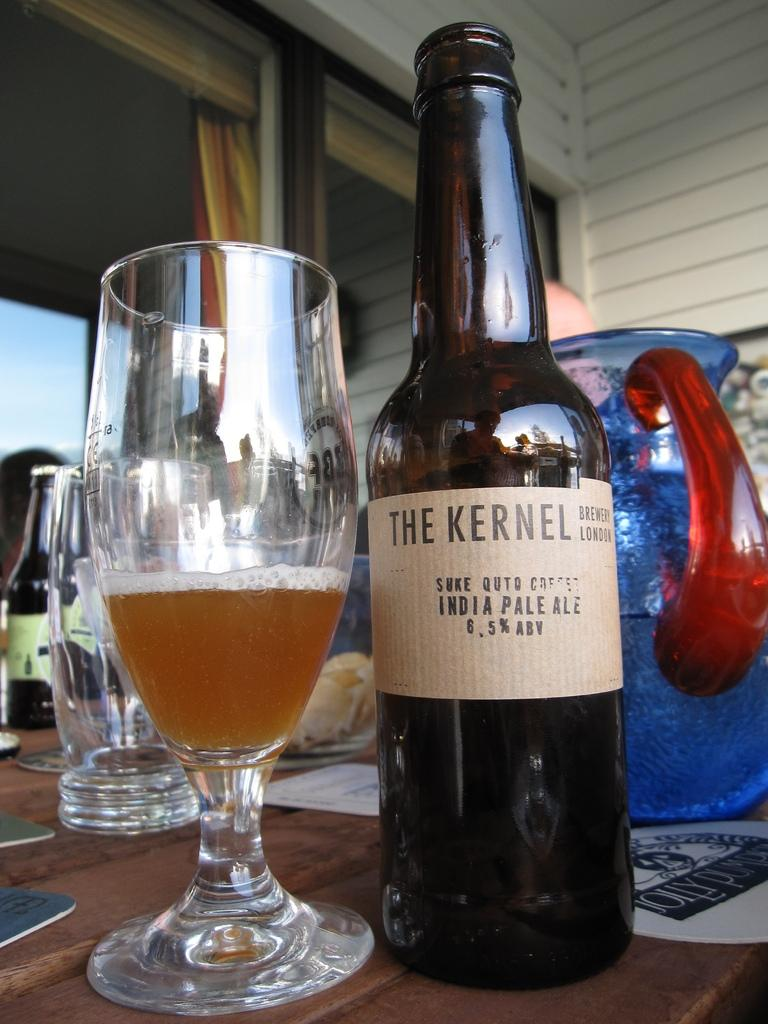<image>
Write a terse but informative summary of the picture. A bottle of beer sits bya half full glass from The Kernel Brewery London. 